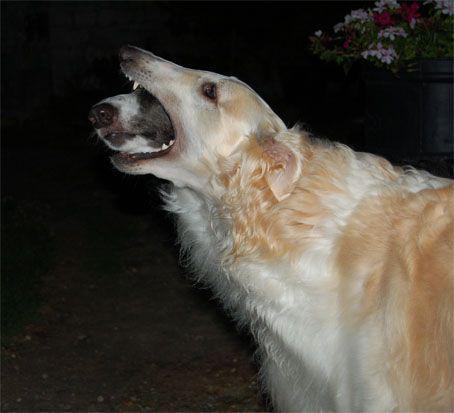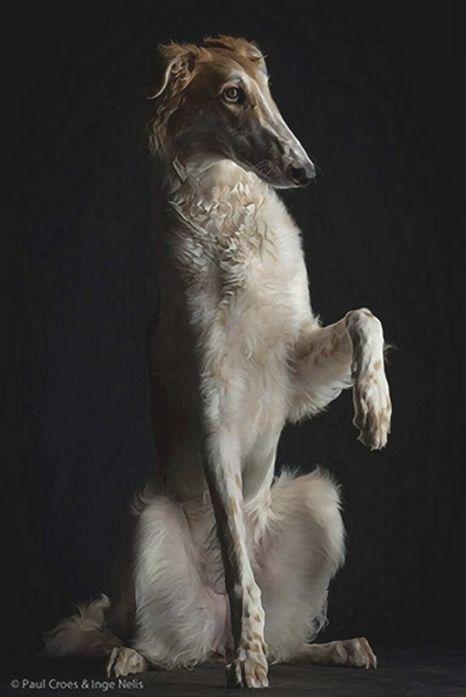The first image is the image on the left, the second image is the image on the right. Given the left and right images, does the statement "One of the dogs is sitting on its haunches." hold true? Answer yes or no. Yes. The first image is the image on the left, the second image is the image on the right. For the images displayed, is the sentence "One dog is sitting on its bottom." factually correct? Answer yes or no. Yes. 